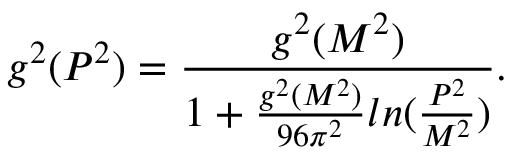Convert formula to latex. <formula><loc_0><loc_0><loc_500><loc_500>g ^ { 2 } ( P ^ { 2 } ) = \frac { g ^ { 2 } ( M ^ { 2 } ) } { 1 + \frac { g ^ { 2 } ( M ^ { 2 } ) } { 9 6 \pi ^ { 2 } } \ln ( \frac { P ^ { 2 } } { M ^ { 2 } } ) } .</formula> 